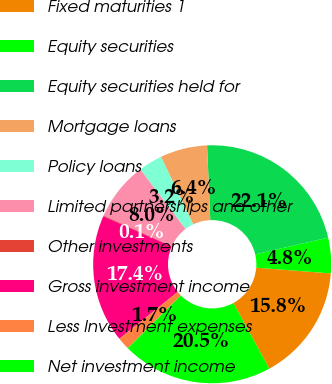Convert chart to OTSL. <chart><loc_0><loc_0><loc_500><loc_500><pie_chart><fcel>Fixed maturities 1<fcel>Equity securities<fcel>Equity securities held for<fcel>Mortgage loans<fcel>Policy loans<fcel>Limited partnerships and other<fcel>Other investments<fcel>Gross investment income<fcel>Less Investment expenses<fcel>Net investment income<nl><fcel>15.81%<fcel>4.82%<fcel>22.09%<fcel>6.39%<fcel>3.25%<fcel>7.96%<fcel>0.11%<fcel>17.38%<fcel>1.68%<fcel>20.52%<nl></chart> 